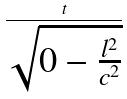Convert formula to latex. <formula><loc_0><loc_0><loc_500><loc_500>\frac { t } { \sqrt { 0 - \frac { l ^ { 2 } } { c ^ { 2 } } } }</formula> 